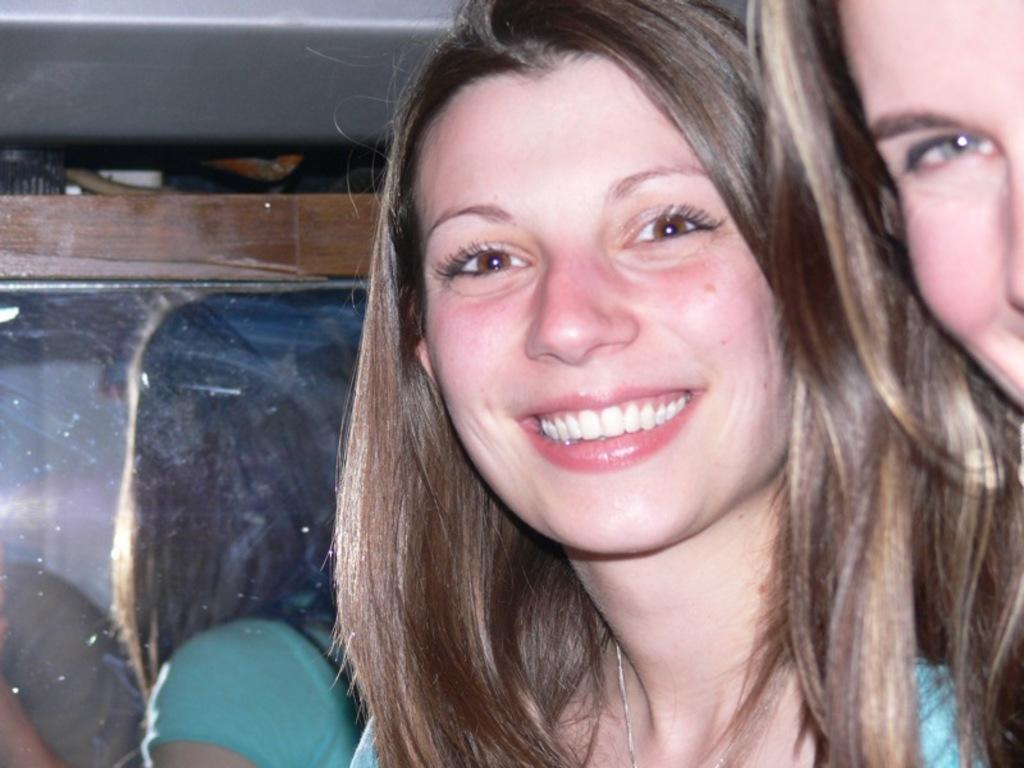Could you give a brief overview of what you see in this image? This is the woman smiling. This looks like a mirror with a wooden frame. I can see the reflection of a woman. At the right side of the image, I can see another woman. 